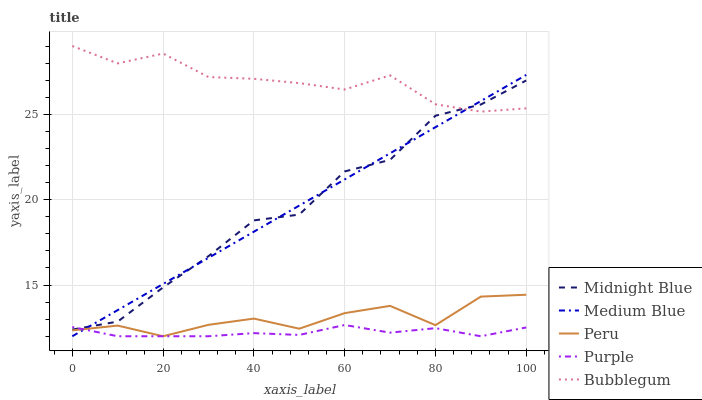Does Purple have the minimum area under the curve?
Answer yes or no. Yes. Does Bubblegum have the maximum area under the curve?
Answer yes or no. Yes. Does Medium Blue have the minimum area under the curve?
Answer yes or no. No. Does Medium Blue have the maximum area under the curve?
Answer yes or no. No. Is Medium Blue the smoothest?
Answer yes or no. Yes. Is Midnight Blue the roughest?
Answer yes or no. Yes. Is Bubblegum the smoothest?
Answer yes or no. No. Is Bubblegum the roughest?
Answer yes or no. No. Does Purple have the lowest value?
Answer yes or no. Yes. Does Bubblegum have the lowest value?
Answer yes or no. No. Does Bubblegum have the highest value?
Answer yes or no. Yes. Does Medium Blue have the highest value?
Answer yes or no. No. Is Peru less than Midnight Blue?
Answer yes or no. Yes. Is Midnight Blue greater than Peru?
Answer yes or no. Yes. Does Medium Blue intersect Purple?
Answer yes or no. Yes. Is Medium Blue less than Purple?
Answer yes or no. No. Is Medium Blue greater than Purple?
Answer yes or no. No. Does Peru intersect Midnight Blue?
Answer yes or no. No. 